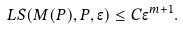Convert formula to latex. <formula><loc_0><loc_0><loc_500><loc_500>L S ( M ( P ) , P , \epsilon ) \leq C \epsilon ^ { m + 1 } .</formula> 